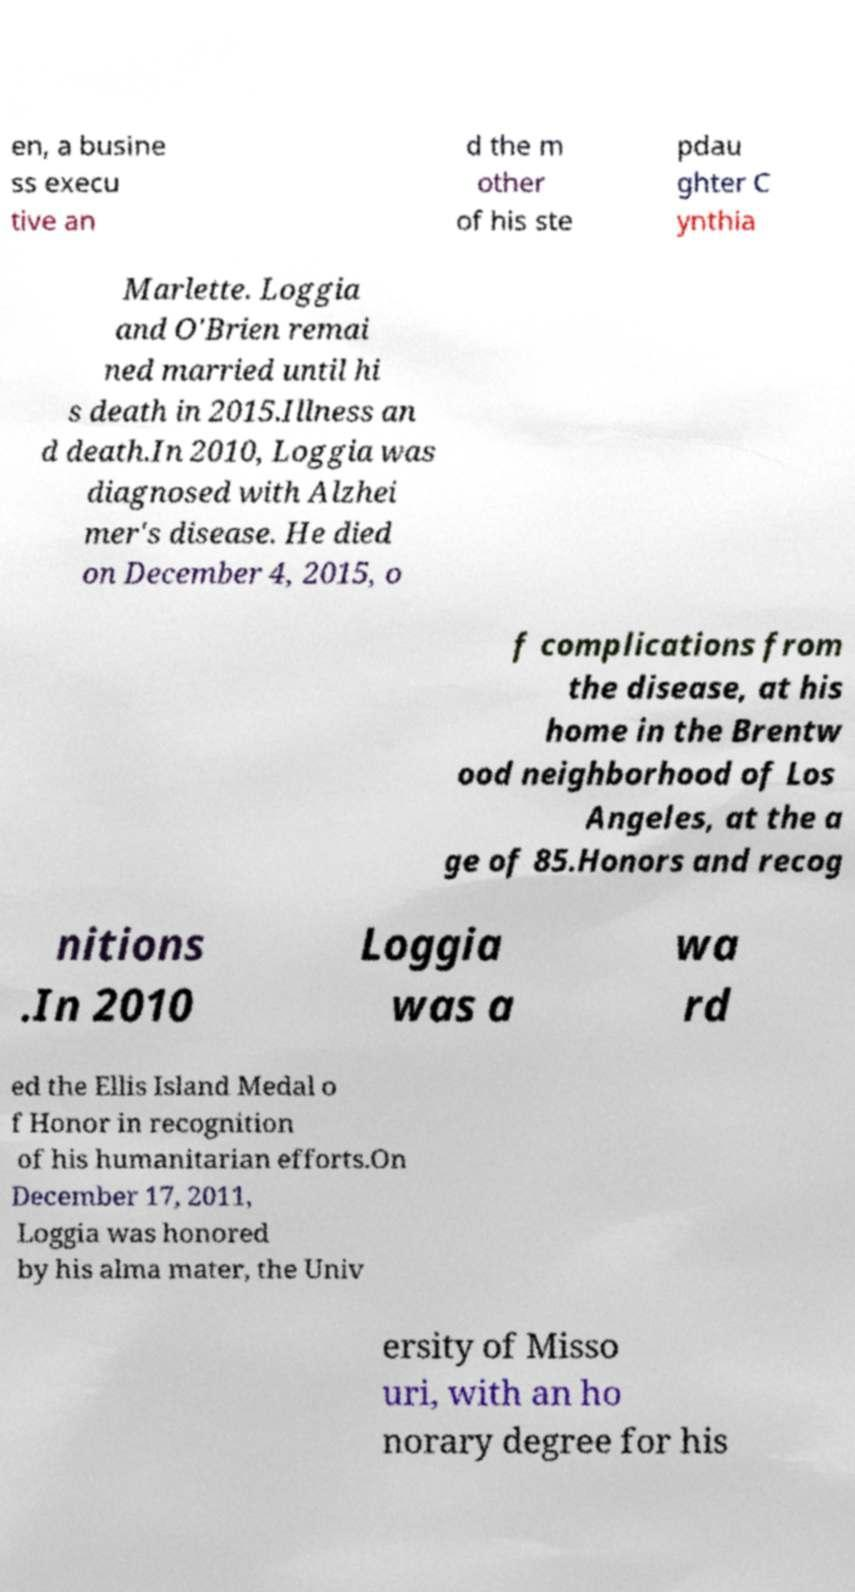Could you extract and type out the text from this image? en, a busine ss execu tive an d the m other of his ste pdau ghter C ynthia Marlette. Loggia and O'Brien remai ned married until hi s death in 2015.Illness an d death.In 2010, Loggia was diagnosed with Alzhei mer's disease. He died on December 4, 2015, o f complications from the disease, at his home in the Brentw ood neighborhood of Los Angeles, at the a ge of 85.Honors and recog nitions .In 2010 Loggia was a wa rd ed the Ellis Island Medal o f Honor in recognition of his humanitarian efforts.On December 17, 2011, Loggia was honored by his alma mater, the Univ ersity of Misso uri, with an ho norary degree for his 